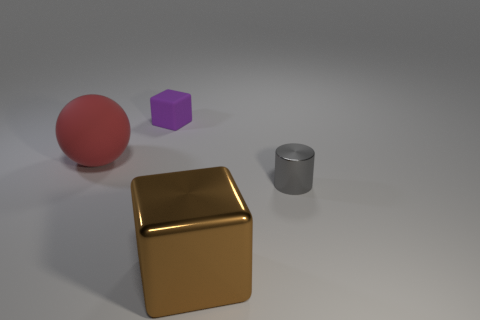Add 1 big cyan matte objects. How many objects exist? 5 Subtract all cylinders. How many objects are left? 3 Add 2 purple matte objects. How many purple matte objects exist? 3 Subtract 0 brown spheres. How many objects are left? 4 Subtract all large purple metallic blocks. Subtract all large metal blocks. How many objects are left? 3 Add 2 gray things. How many gray things are left? 3 